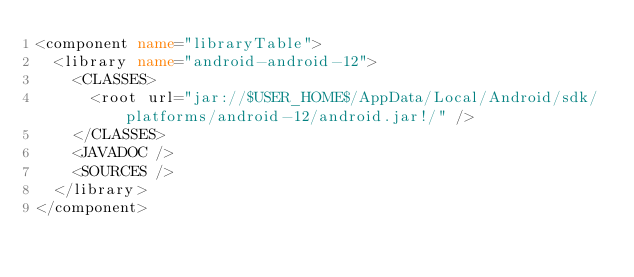<code> <loc_0><loc_0><loc_500><loc_500><_XML_><component name="libraryTable">
  <library name="android-android-12">
    <CLASSES>
      <root url="jar://$USER_HOME$/AppData/Local/Android/sdk/platforms/android-12/android.jar!/" />
    </CLASSES>
    <JAVADOC />
    <SOURCES />
  </library>
</component></code> 